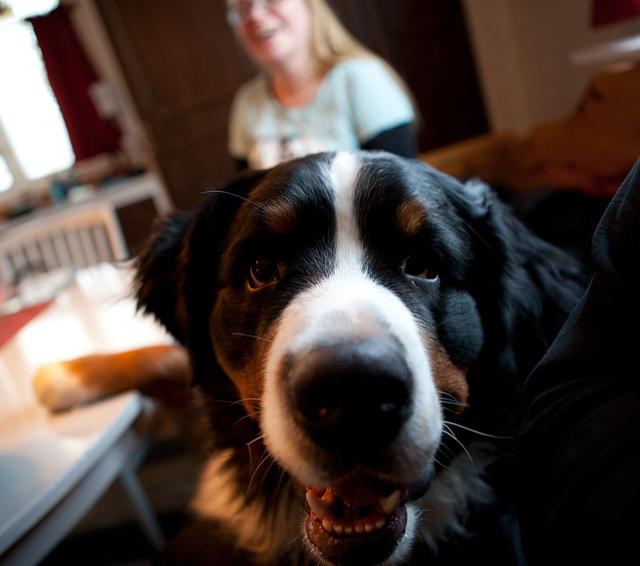Where is the dog looking?
Quick response, please. Camera. Is the dog a poodle?
Write a very short answer. No. Does the dog look healthy?
Quick response, please. Yes. 